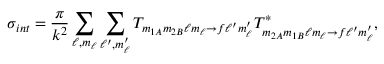Convert formula to latex. <formula><loc_0><loc_0><loc_500><loc_500>\sigma _ { i n t } = \frac { \pi } { k ^ { 2 } } \sum _ { \ell , m _ { \ell } } \sum _ { \ell ^ { \prime } , m _ { \ell } ^ { \prime } } T _ { m _ { 1 A } m _ { 2 B } \ell m _ { \ell } \rightarrow f \ell ^ { \prime } m _ { \ell } ^ { \prime } } T _ { m _ { 2 A } m _ { 1 B } \ell m _ { \ell } \rightarrow f \ell ^ { \prime } m _ { \ell } ^ { \prime } } ^ { * } ,</formula> 